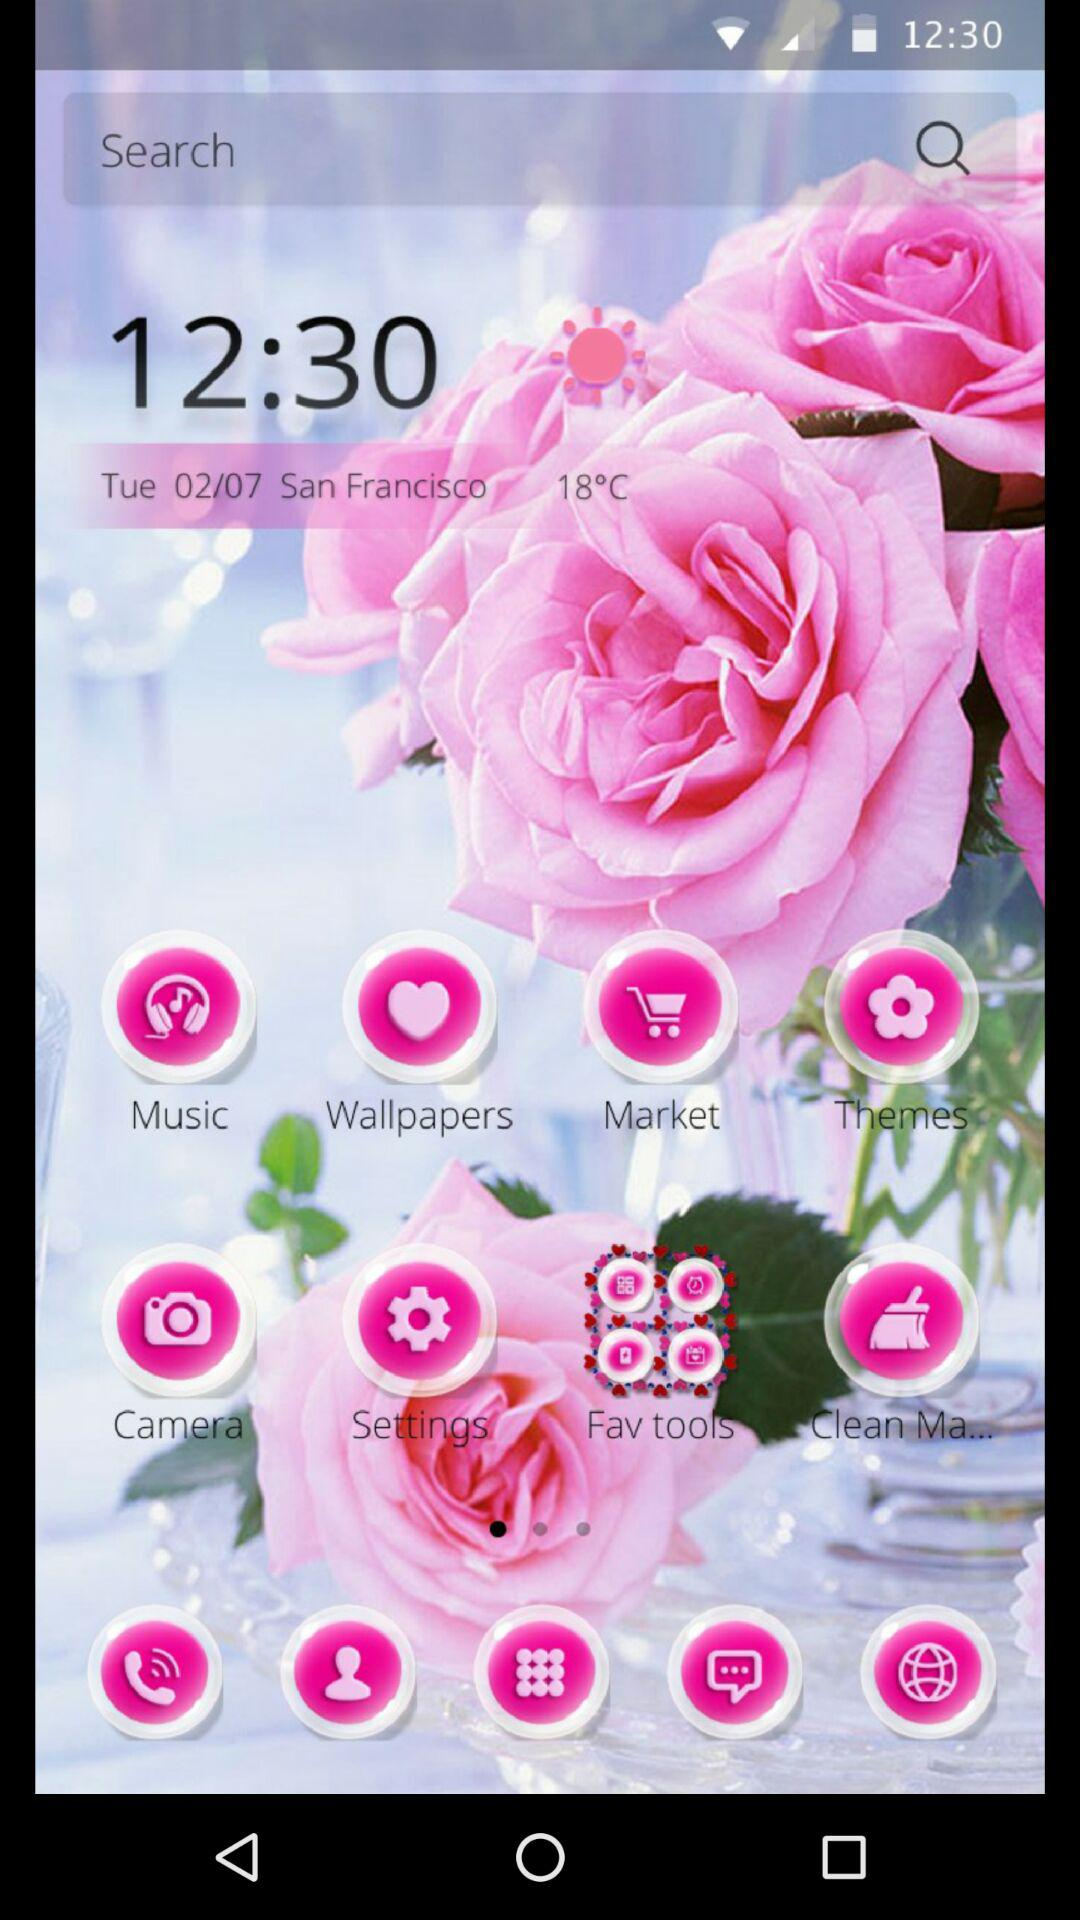What is the location? The location is San Francisco. 